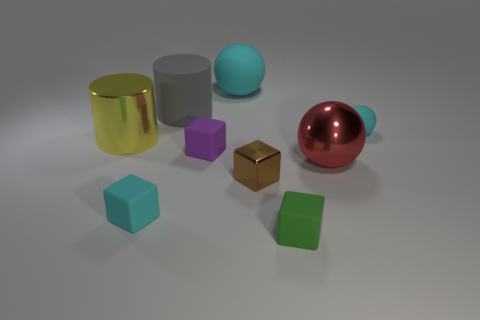Is the number of yellow cylinders greater than the number of big green cylinders?
Offer a terse response. Yes. Does the tiny cyan object that is on the right side of the big red sphere have the same material as the large cylinder behind the large yellow object?
Keep it short and to the point. Yes. What is the material of the yellow cylinder?
Provide a succinct answer. Metal. Is the number of tiny rubber objects on the right side of the large red shiny ball greater than the number of brown rubber cylinders?
Offer a terse response. Yes. How many small things are on the right side of the big sphere that is in front of the big rubber object to the right of the purple matte thing?
Your answer should be very brief. 1. There is a big thing that is on the left side of the purple cube and on the right side of the large yellow object; what is its material?
Offer a very short reply. Rubber. The large matte ball is what color?
Keep it short and to the point. Cyan. Are there more big yellow metallic things that are to the left of the purple matte object than green cubes that are behind the big yellow cylinder?
Make the answer very short. Yes. There is a rubber block right of the big cyan thing; what is its color?
Provide a short and direct response. Green. There is a green block that is on the right side of the cyan rubber cube; is its size the same as the metal object behind the purple matte thing?
Provide a succinct answer. No. 